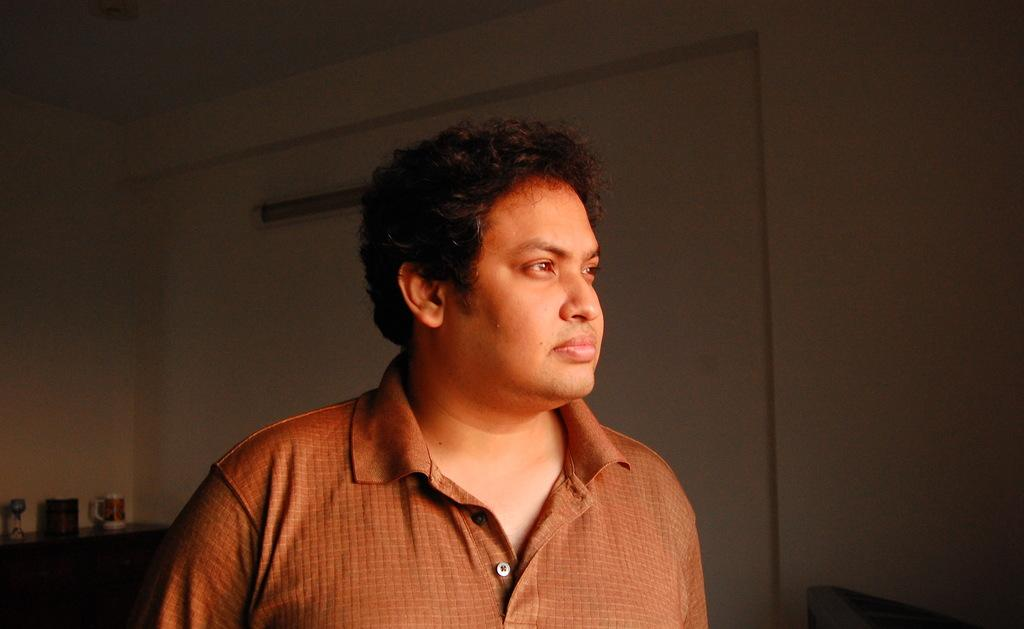Who is present in the image? There is a man in the image. What is the man wearing? The man is wearing a brown shirt. What can be seen on the left side of the image? There is a table on the left side of the image. What is on the table? There is a cup on the table, and there are other things on the table as well. What is visible in the background of the image? There is a wall in the background of the image. What type of heart can be seen beating in the image? There is no heart visible in the image; it is a man standing near a table with a cup and other objects. What level of difficulty is the parcel being delivered at in the image? There is no parcel or indication of difficulty in the image; it features a man standing near a table with a cup and other objects. 